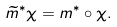<formula> <loc_0><loc_0><loc_500><loc_500>\widetilde { m } ^ { * } \chi = m ^ { * } \circ \chi .</formula> 